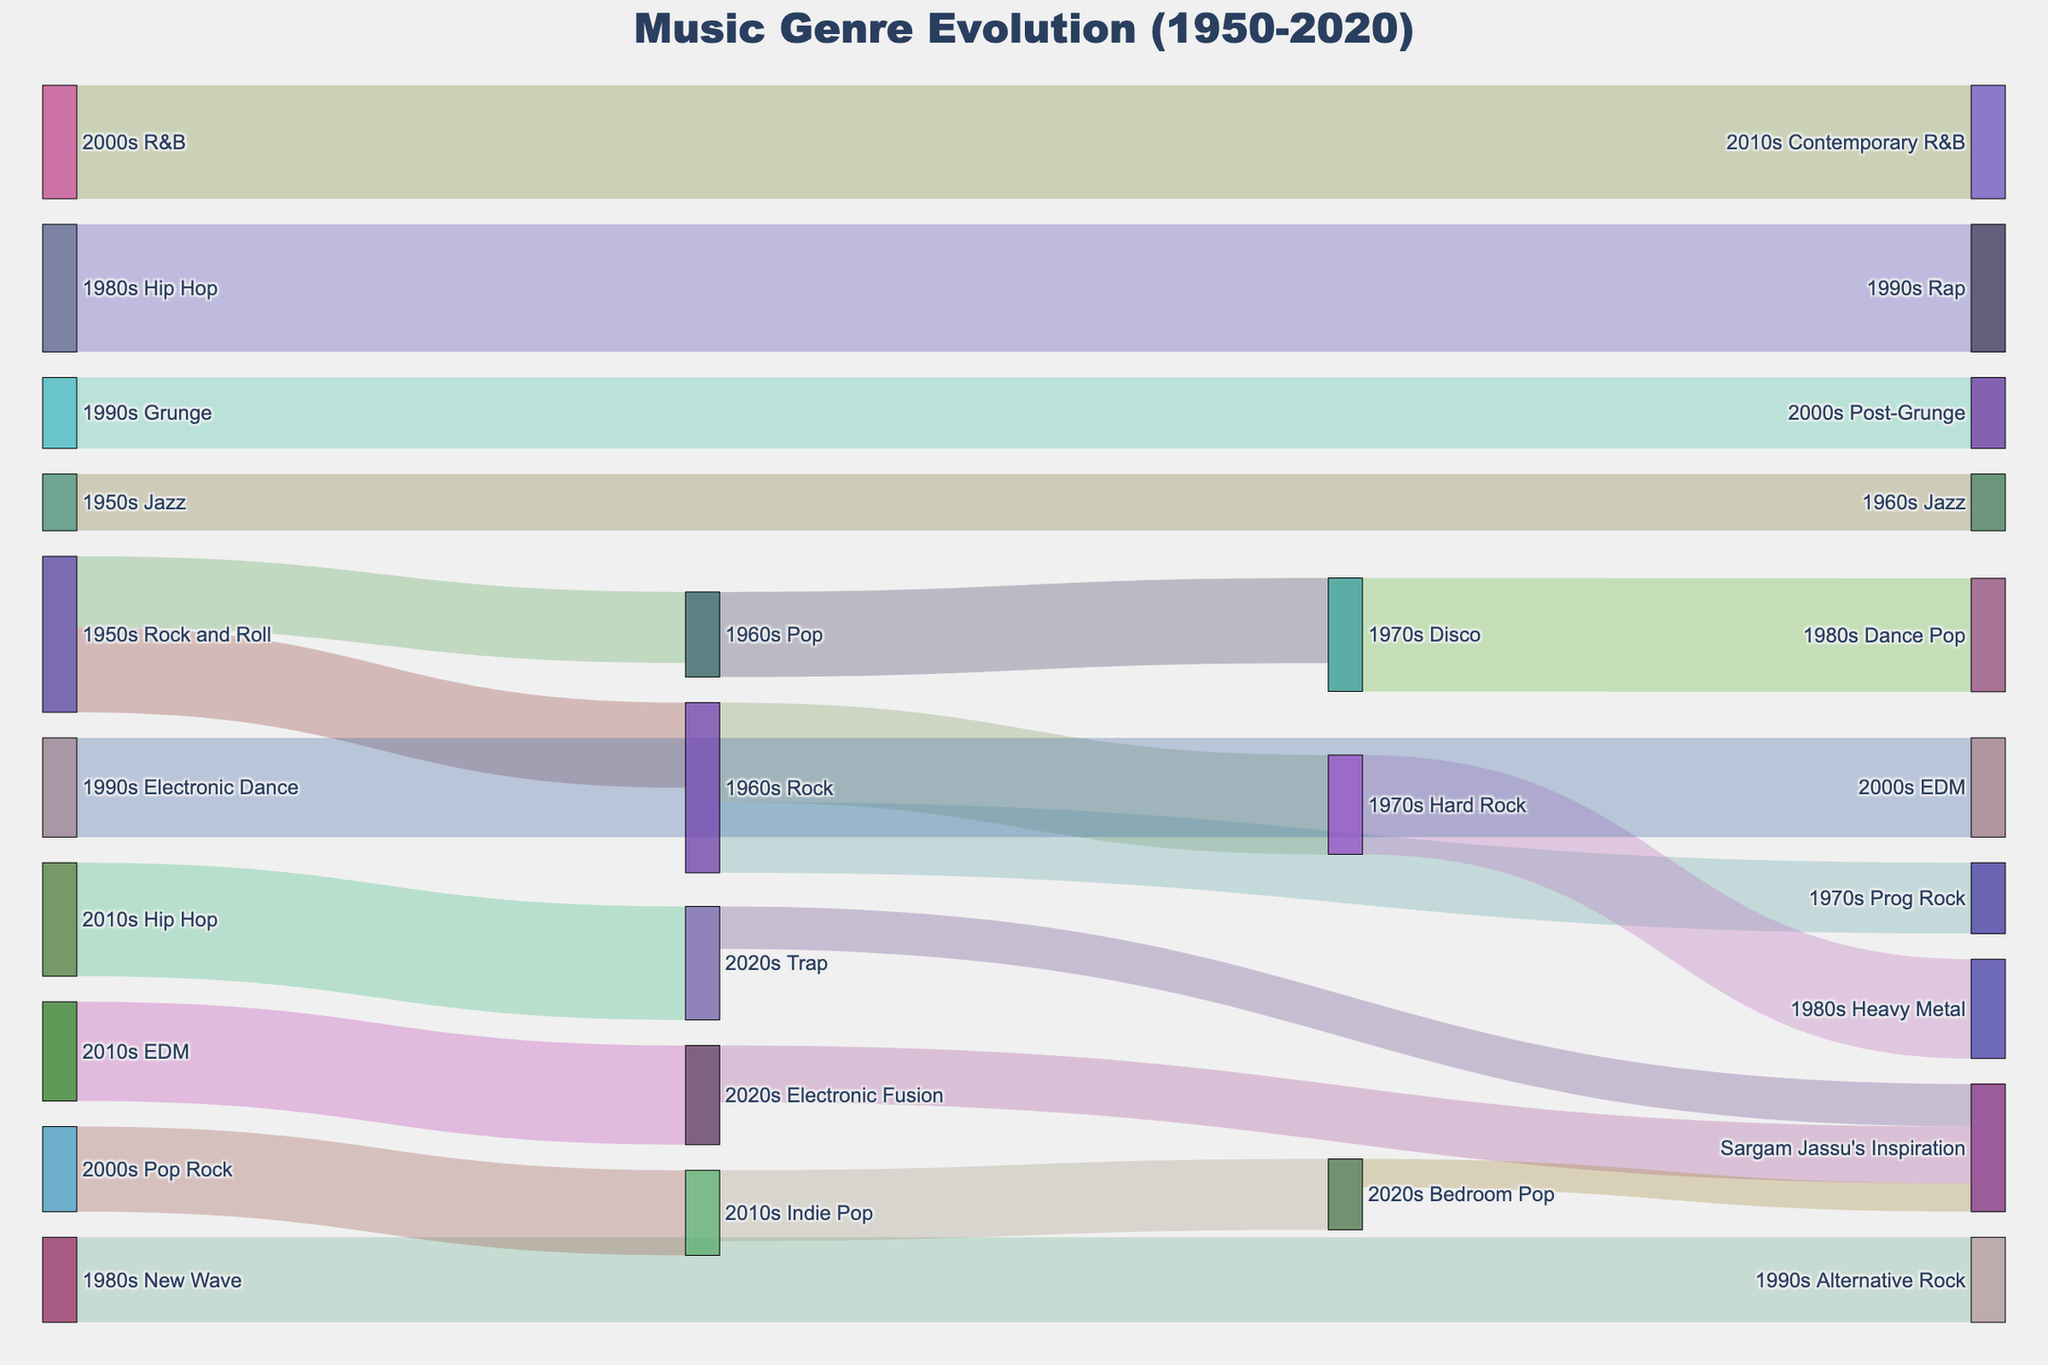How many genres from the 1950s evolved into Rock in the 1960s? To find the answer, look for the flows originating from "1950s" and leading to "1960s Rock". There's only one flow: "1950s Rock and Roll" to "1960s Rock".
Answer: 1 Which genre in the 2000s has the highest flow value leading into the 2010s? From the flows of the 2000s to the 2010s, compare the values: "2000s R&B" to "2010s Contemporary R&B" (value 40) and "2000s Pop Rock" to "2010s Indie Pop" (value 30). The highest value is 40.
Answer: Contemporary R&B What are the major genres that contributed to Sargam Jassu's Inspiration in the 2020s? Look at the flows leading into "Sargam Jassu's Inspiration" in the 2020s. The contributing genres are "2020s Electronic Fusion", "2020s Trap", and "2020s Bedroom Pop".
Answer: Electronic Fusion, Trap, Bedroom Pop What is the combined value of genres transitioning from the 1990s to the 2000s? Sum the values of flows from the 1990s to the 2000s: "1990s Grunge" to "2000s Post-Grunge" (25) and "1990s Electronic Dance" to "2000s EDM" (35). The combined value is 25 + 35.
Answer: 60 Which decade has the highest variety of genre transitions? Count the unique transitions in each decade. 1980s has transitions: New Wave to Alternative Rock, Hip Hop to Rap, totaling 2. 1990s has 2 transitions as well. Other decades have fewer transitions.
Answer: 1980s and 1990s How many different genres in the 2010s lead to genres in the 2020s? Count the number of unique genres in the 2010s flowing into the 2020s. Here's the list: "2010s EDM" to "2020s Electronic Fusion", "2010s Hip Hop" to "2020s Trap", and "2010s Indie Pop" to "2020s Bedroom Pop".
Answer: 3 Between 1980s New Wave and 1980s Hip Hop, which genre had a greater influence on the 1990s? Compare the flow values: "1980s New Wave" to "1990s Alternative Rock" (30) and "1980s Hip Hop" to "1990s Rap" (45). Hip Hop has a greater influence with a value of 45.
Answer: 1980s Hip Hop 